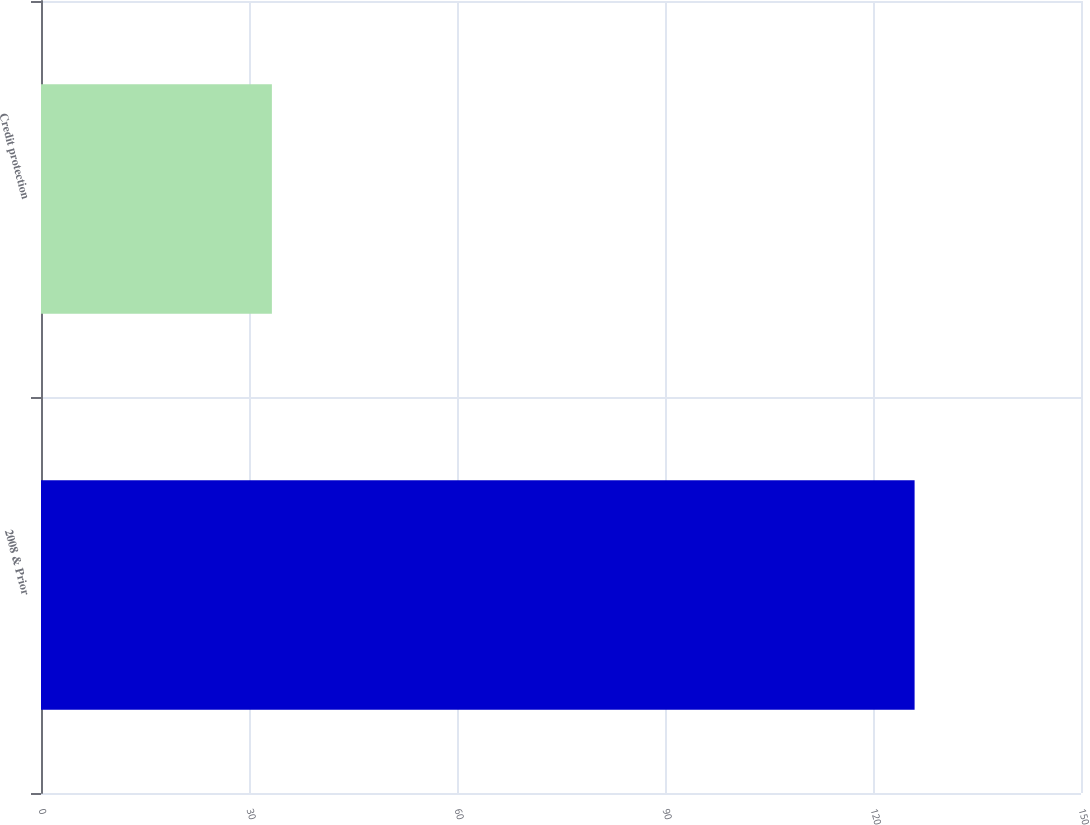<chart> <loc_0><loc_0><loc_500><loc_500><bar_chart><fcel>2008 & Prior<fcel>Credit protection<nl><fcel>126<fcel>33.3<nl></chart> 